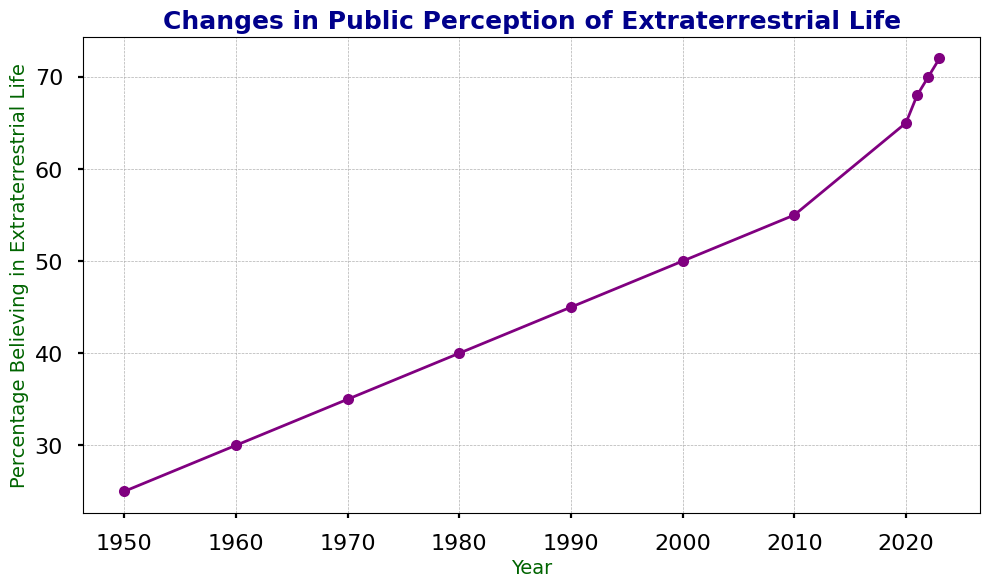Which year saw the highest percentage of people believing in extraterrestrial life? The figure shows that the year 2023 has the highest point on the line chart.
Answer: 2023 How much did the percentage of people believing in extraterrestrial life increase from 1950 to 1990? The percentage in 1950 was 25%, and in 1990 it was 45%. The increase is calculated as 45% - 25% = 20%.
Answer: 20% What is the average percentage of belief in extraterrestrial life from 2000 to 2023? Calculate the average percentage for the years 2000 (50%), 2010 (55%), 2020 (65%), 2021 (68%), 2022 (70%), and 2023 (72%). Sum these values (50+55+65+68+70+72=380) and divide by the number of years (6). 380/6 = 63.33%.
Answer: 63.33% Which decade saw the highest increase in the percentage of people believing in extraterrestrial life? Compare the increases in each decade. From 1950 to 1960, the increase is 5%. From 1960 to 1970, the increase is 5%. From 1970 to 1980, the increase is 5%. From 1980 to 1990, the increase is 5%. From 1990 to 2000, the increase is 5%. From 2000 to 2010, the increase is 5%. From 2010 to 2020, the increase is 10%, which is the highest.
Answer: 2010-2020 How many total years are plotted in the figure? The x-axis of the figure ranges from 1950 to 2023. Counting all the years individually shown, there are 11 years.
Answer: 11 In which year did the belief in extraterrestrial life cross 50%? The figure shows that 2000 is the first year where the percentage is 50%.
Answer: 2000 Calculate the rate of increase in belief in extraterrestrial life from 1950 to 2023. The rate of increase is calculated as (Final Value - Initial Value) / Number of Years. From 1950 to 2023, the percentage increased from 25% to 72%. The calculation is (72% - 25%) / (2023 - 1950) = 47% / 73 years ≈ 0.64% per year.
Answer: 0.64% per year Compare the percentage of people believing in extraterrestrial life in 1960 with that in 2020. From the figure, in 1960, the percentage was 30%, and in 2020 it was 65%. So, 65% > 30%.
Answer: 2020 > 1960 By how much did the belief in extraterrestrial life increase from 2021 to 2023? The percentage in 2021 was 68%, and in 2023 it was 72%. The increase is calculated as 72% - 68% = 4%.
Answer: 4% 